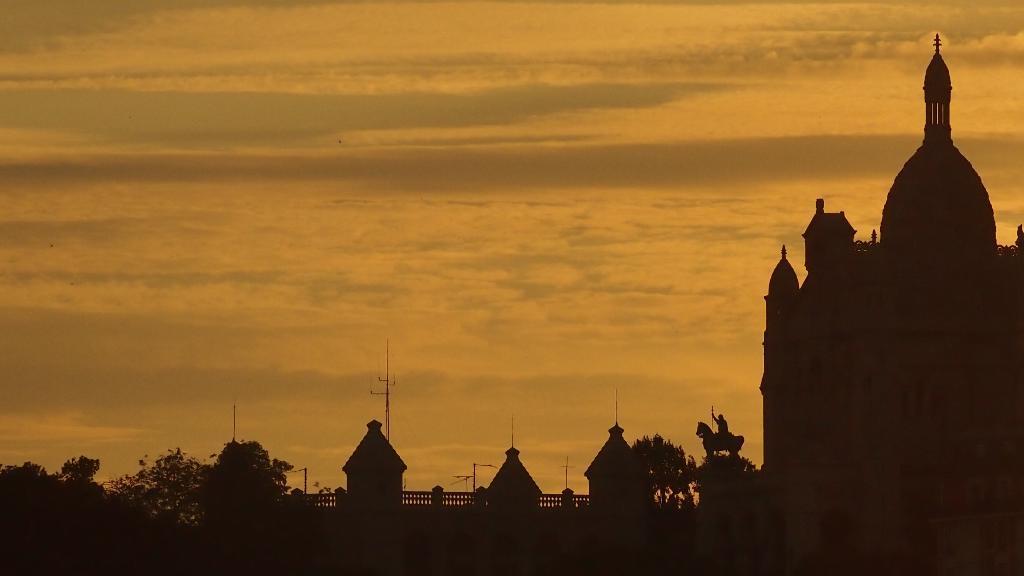Can you describe this image briefly? In this image there are some buildings, statue, pole, railing, trees. And at the top there is sky. 